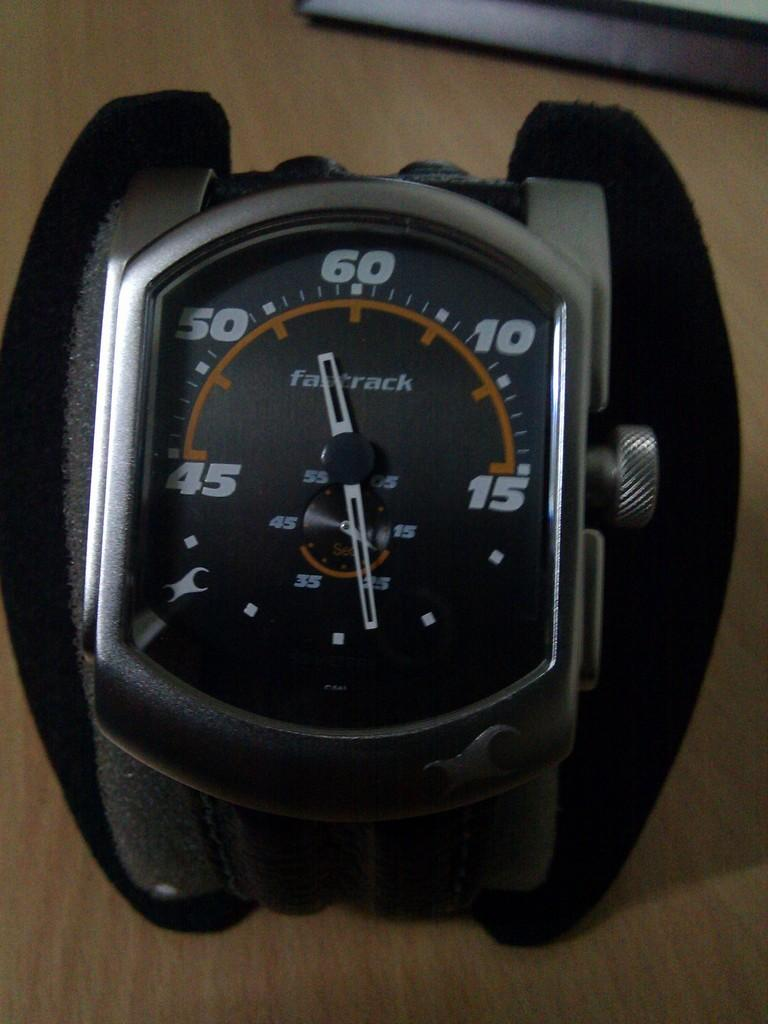Provide a one-sentence caption for the provided image. Face of a watch which says the word Fastrack on it. 